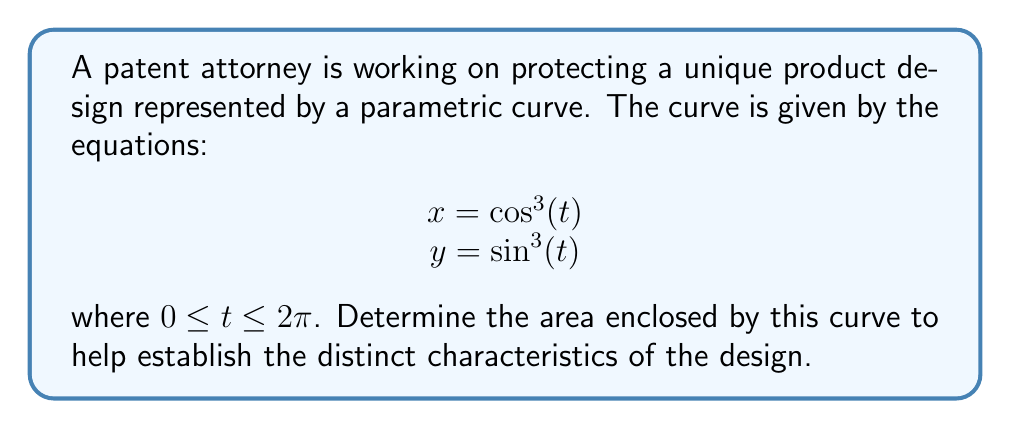Can you solve this math problem? To find the area enclosed by a parametric curve, we can use the formula:

$$A = \frac{1}{2} \int_a^b [x(t)y'(t) - y(t)x'(t)] dt$$

where $a$ and $b$ are the start and end values of the parameter $t$.

1) First, let's find $x'(t)$ and $y'(t)$:
   $x'(t) = -3\cos^2(t)\sin(t)$
   $y'(t) = 3\sin^2(t)\cos(t)$

2) Now, let's substitute these into our formula:
   $$A = \frac{1}{2} \int_0^{2\pi} [\cos^3(t)(3\sin^2(t)\cos(t)) - \sin^3(t)(-3\cos^2(t)\sin(t))] dt$$

3) Simplify:
   $$A = \frac{1}{2} \int_0^{2\pi} [3\cos^4(t)\sin^2(t) + 3\cos^2(t)\sin^4(t)] dt$$
   $$A = \frac{3}{2} \int_0^{2\pi} \cos^2(t)\sin^2(t)[\cos^2(t) + \sin^2(t)] dt$$

4) We know that $\cos^2(t) + \sin^2(t) = 1$, so:
   $$A = \frac{3}{2} \int_0^{2\pi} \cos^2(t)\sin^2(t) dt$$

5) Using the identity $\cos^2(t) = \frac{1+\cos(2t)}{2}$ and $\sin^2(t) = \frac{1-\cos(2t)}{2}$:
   $$A = \frac{3}{2} \int_0^{2\pi} \frac{1-\cos^2(2t)}{4} dt$$

6) Simplify:
   $$A = \frac{3}{8} \int_0^{2\pi} [1-\cos^2(2t)] dt$$
   $$A = \frac{3}{8} [t - \frac{t}{2} - \frac{\sin(4t)}{8}]_0^{2\pi}$$

7) Evaluate:
   $$A = \frac{3}{8} [2\pi - \pi - 0] = \frac{3\pi}{8}$$

Therefore, the area enclosed by the parametric curve is $\frac{3\pi}{8}$.
Answer: $\frac{3\pi}{8}$ square units 